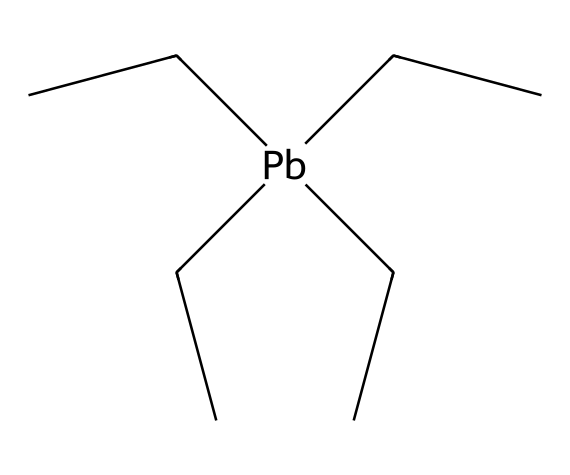What is the central metal atom in this compound? The SMILES representation shows a lead atom (Pb) at the center of the tetraethyl lead structure, connected to four ethyl groups.
Answer: lead How many ethyl groups are present in the tetraethyl lead structure? The structure contains four ethyl groups, as indicated by the four "CC" units connected to the lead atom.
Answer: four What is the coordination number of the lead atom in this compound? The lead atom is bonded to four ethyl groups, resulting in a coordination number of four.
Answer: four Is tetraethyl lead a coordination compound? Yes, tetraethyl lead is a coordination compound because it consists of a central metal atom bonded to ligands (in this case, ethyl groups).
Answer: yes What type of bonds are present between the lead atom and the ethyl groups? There are coordinate covalent bonds formed between the lead atom and the ethyl groups, as the lead shares its electrons with the ethyl carbons.
Answer: coordinate covalent What is the oxidation state of lead in tetraethyl lead? In tetraethyl lead, lead is in the zero oxidation state as it is uncharged and is bonded to the ethyl groups without any additional charge.
Answer: zero What property made tetraethyl lead a controversial additive in gasoline? The presence of lead (Pb) in leaded gasoline raised serious health concerns, particularly related to neurotoxicity and environmental contamination.
Answer: neurotoxicity 